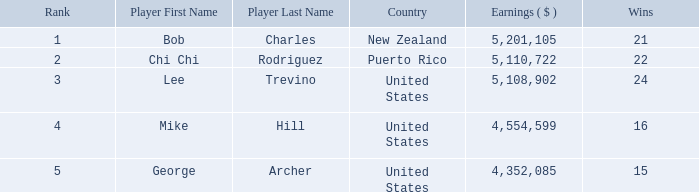Parse the table in full. {'header': ['Rank', 'Player First Name', 'Player Last Name', 'Country', 'Earnings ( $ )', 'Wins'], 'rows': [['1', 'Bob', 'Charles', 'New Zealand', '5,201,105', '21'], ['2', 'Chi Chi', 'Rodriguez', 'Puerto Rico', '5,110,722', '22'], ['3', 'Lee', 'Trevino', 'United States', '5,108,902', '24'], ['4', 'Mike', 'Hill', 'United States', '4,554,599', '16'], ['5', 'George', 'Archer', 'United States', '4,352,085', '15']]} In total, how much did the United States player George Archer earn with Wins lower than 24 and a rank that was higher than 5? 0.0. 